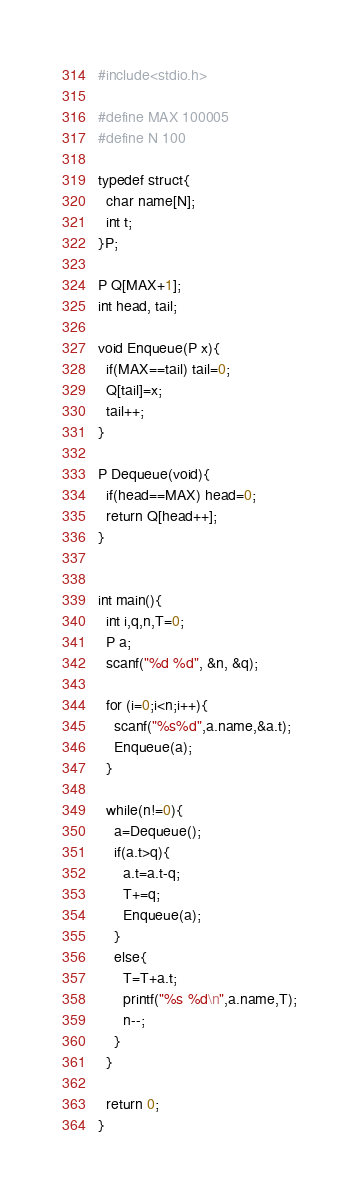Convert code to text. <code><loc_0><loc_0><loc_500><loc_500><_C_>#include<stdio.h>

#define MAX 100005
#define N 100

typedef struct{
  char name[N];
  int t;
}P;

P Q[MAX+1];
int head, tail;

void Enqueue(P x){
  if(MAX==tail) tail=0;
  Q[tail]=x;
  tail++;
}

P Dequeue(void){
  if(head==MAX) head=0;
  return Q[head++];
}


int main(){
  int i,q,n,T=0;
  P a;
  scanf("%d %d", &n, &q);

  for (i=0;i<n;i++){
    scanf("%s%d",a.name,&a.t);
    Enqueue(a);
  }

  while(n!=0){
    a=Dequeue();
    if(a.t>q){
      a.t=a.t-q;
      T+=q;
      Enqueue(a);
    }
    else{
      T=T+a.t;
      printf("%s %d\n",a.name,T);
      n--;
    }
  }

  return 0;
}

</code> 